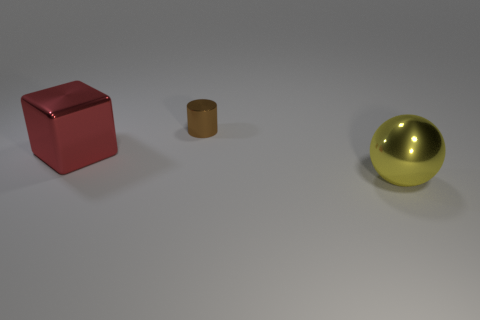Add 1 big yellow shiny spheres. How many objects exist? 4 Subtract all blocks. How many objects are left? 2 Subtract 1 spheres. How many spheres are left? 0 Subtract all purple cylinders. Subtract all brown spheres. How many cylinders are left? 1 Subtract all big gray spheres. Subtract all tiny cylinders. How many objects are left? 2 Add 1 big red blocks. How many big red blocks are left? 2 Add 1 cyan matte spheres. How many cyan matte spheres exist? 1 Subtract 0 gray balls. How many objects are left? 3 